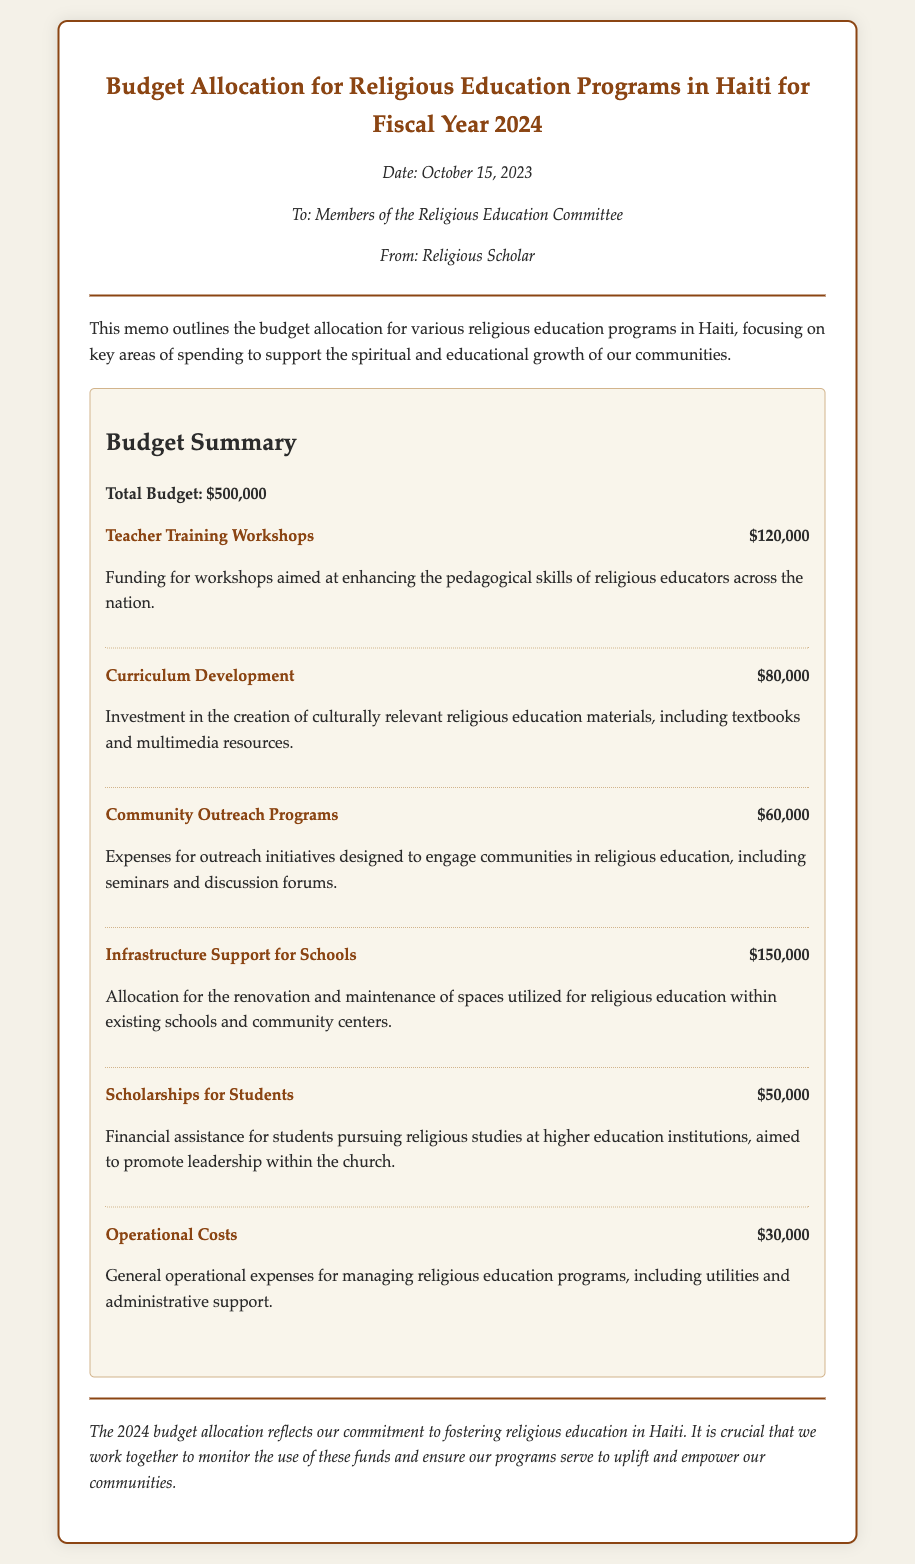what is the total budget for fiscal year 2024? The total budget is explicitly stated in the document as part of the budget summary.
Answer: $500,000 how much is allocated for Teacher Training Workshops? The amount allocated for Teacher Training Workshops is listed under expense items as part of the budget summary.
Answer: $120,000 what is the purpose of the Community Outreach Programs funding? The purpose of the Community Outreach Programs funding is provided in the description associated with the expense item.
Answer: Engage communities in religious education which expense item has the largest allocation? The expense item with the largest allocation can be inferred from the amounts listed in the budget summary.
Answer: Infrastructure Support for Schools how much is designated for scholarships? The amount designated for scholarships is provided in the section detailing expenses for religious education programs.
Answer: $50,000 what type of memo is this document? The type of memo can be determined by the introduction and context presented within the document.
Answer: Budget Allocation Memo who is the memo addressed to? The memo identifies the recipients in the header section detailing the intended audience.
Answer: Members of the Religious Education Committee what are operational costs? The document describes operational costs in relation to managing religious education programs, indicating its purpose.
Answer: General operational expenses which month was the memo issued? The issuing date of the memo is clearly stated in the document under the metadata section.
Answer: October 